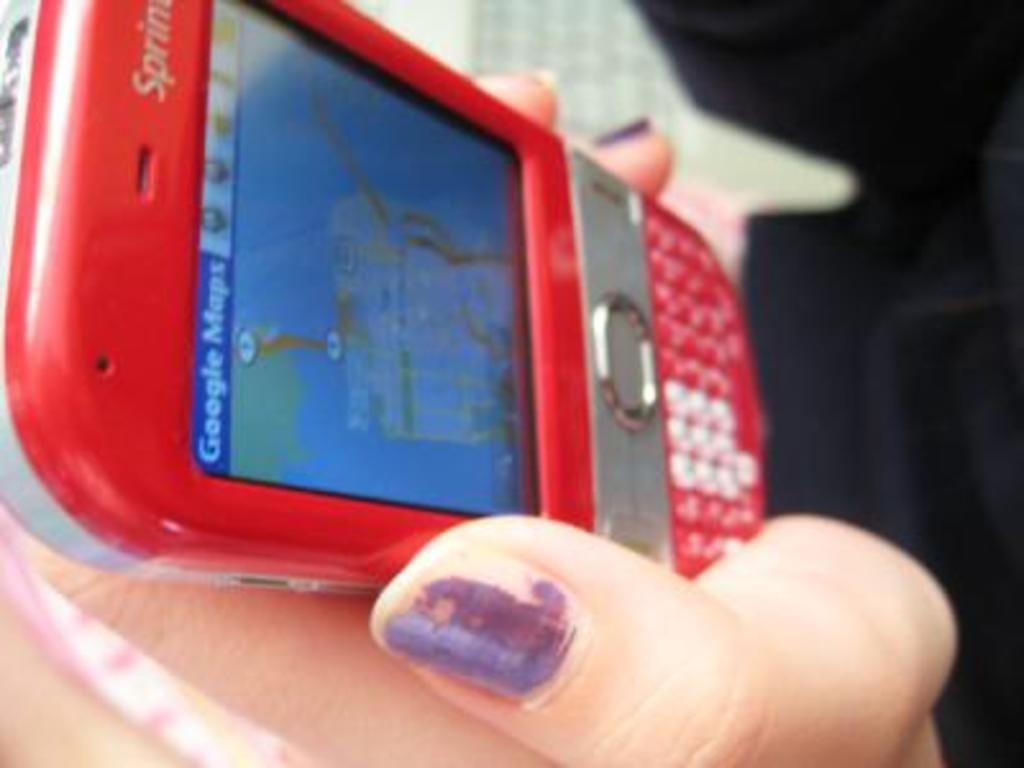<image>
Create a compact narrative representing the image presented. A woman with purple nails is holding a red cell phone and the screen says Google maps. 